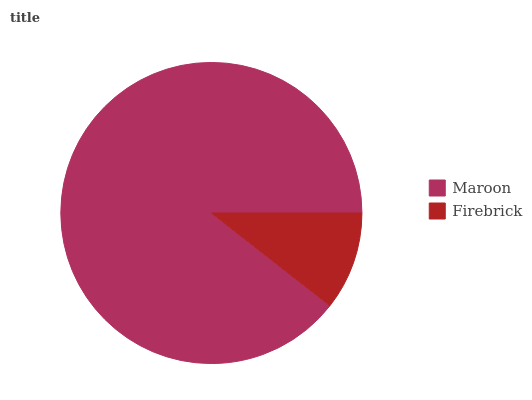Is Firebrick the minimum?
Answer yes or no. Yes. Is Maroon the maximum?
Answer yes or no. Yes. Is Firebrick the maximum?
Answer yes or no. No. Is Maroon greater than Firebrick?
Answer yes or no. Yes. Is Firebrick less than Maroon?
Answer yes or no. Yes. Is Firebrick greater than Maroon?
Answer yes or no. No. Is Maroon less than Firebrick?
Answer yes or no. No. Is Maroon the high median?
Answer yes or no. Yes. Is Firebrick the low median?
Answer yes or no. Yes. Is Firebrick the high median?
Answer yes or no. No. Is Maroon the low median?
Answer yes or no. No. 